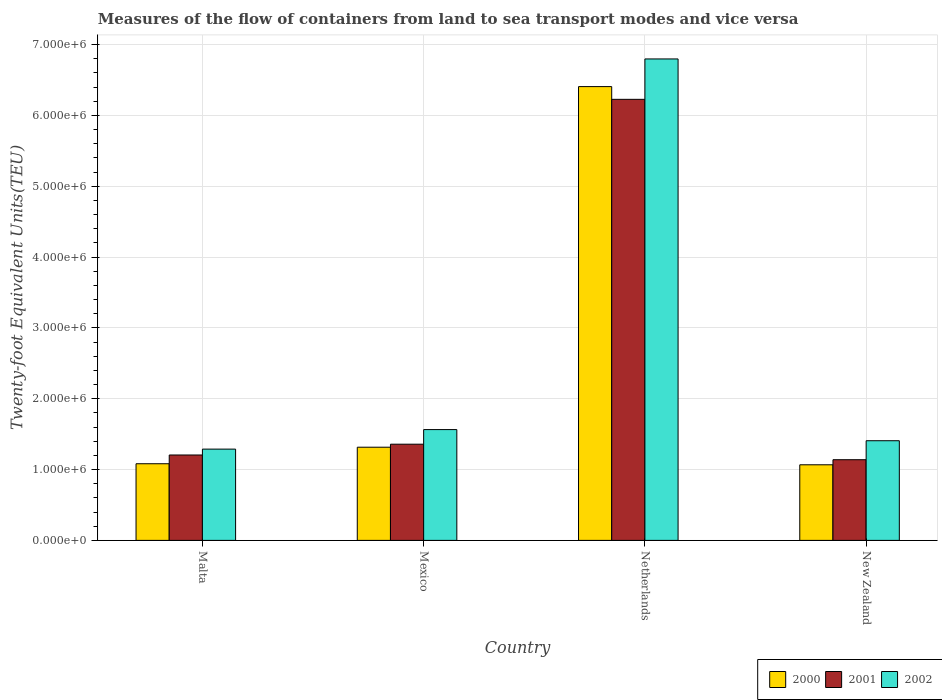How many different coloured bars are there?
Provide a succinct answer. 3. How many groups of bars are there?
Your answer should be very brief. 4. Are the number of bars on each tick of the X-axis equal?
Keep it short and to the point. Yes. How many bars are there on the 1st tick from the left?
Your answer should be very brief. 3. What is the label of the 3rd group of bars from the left?
Give a very brief answer. Netherlands. What is the container port traffic in 2001 in New Zealand?
Your response must be concise. 1.14e+06. Across all countries, what is the maximum container port traffic in 2001?
Your response must be concise. 6.23e+06. Across all countries, what is the minimum container port traffic in 2002?
Offer a very short reply. 1.29e+06. In which country was the container port traffic in 2000 maximum?
Provide a succinct answer. Netherlands. In which country was the container port traffic in 2000 minimum?
Offer a very short reply. New Zealand. What is the total container port traffic in 2000 in the graph?
Offer a terse response. 9.87e+06. What is the difference between the container port traffic in 2002 in Malta and that in Netherlands?
Ensure brevity in your answer.  -5.51e+06. What is the difference between the container port traffic in 2001 in New Zealand and the container port traffic in 2000 in Mexico?
Your answer should be very brief. -1.77e+05. What is the average container port traffic in 2002 per country?
Ensure brevity in your answer.  2.76e+06. What is the difference between the container port traffic of/in 2000 and container port traffic of/in 2001 in Mexico?
Offer a very short reply. -4.24e+04. What is the ratio of the container port traffic in 2001 in Malta to that in New Zealand?
Keep it short and to the point. 1.06. Is the container port traffic in 2000 in Malta less than that in Netherlands?
Provide a succinct answer. Yes. Is the difference between the container port traffic in 2000 in Malta and Mexico greater than the difference between the container port traffic in 2001 in Malta and Mexico?
Offer a terse response. No. What is the difference between the highest and the second highest container port traffic in 2002?
Your answer should be very brief. 5.23e+06. What is the difference between the highest and the lowest container port traffic in 2000?
Offer a terse response. 5.34e+06. In how many countries, is the container port traffic in 2002 greater than the average container port traffic in 2002 taken over all countries?
Your answer should be compact. 1. How many countries are there in the graph?
Offer a very short reply. 4. Does the graph contain any zero values?
Offer a very short reply. No. Where does the legend appear in the graph?
Offer a terse response. Bottom right. How many legend labels are there?
Provide a short and direct response. 3. What is the title of the graph?
Ensure brevity in your answer.  Measures of the flow of containers from land to sea transport modes and vice versa. What is the label or title of the Y-axis?
Offer a very short reply. Twenty-foot Equivalent Units(TEU). What is the Twenty-foot Equivalent Units(TEU) of 2000 in Malta?
Provide a short and direct response. 1.08e+06. What is the Twenty-foot Equivalent Units(TEU) in 2001 in Malta?
Offer a very short reply. 1.21e+06. What is the Twenty-foot Equivalent Units(TEU) in 2002 in Malta?
Make the answer very short. 1.29e+06. What is the Twenty-foot Equivalent Units(TEU) in 2000 in Mexico?
Keep it short and to the point. 1.32e+06. What is the Twenty-foot Equivalent Units(TEU) of 2001 in Mexico?
Your answer should be very brief. 1.36e+06. What is the Twenty-foot Equivalent Units(TEU) of 2002 in Mexico?
Offer a terse response. 1.56e+06. What is the Twenty-foot Equivalent Units(TEU) in 2000 in Netherlands?
Your answer should be very brief. 6.41e+06. What is the Twenty-foot Equivalent Units(TEU) of 2001 in Netherlands?
Your answer should be very brief. 6.23e+06. What is the Twenty-foot Equivalent Units(TEU) of 2002 in Netherlands?
Keep it short and to the point. 6.80e+06. What is the Twenty-foot Equivalent Units(TEU) of 2000 in New Zealand?
Provide a short and direct response. 1.07e+06. What is the Twenty-foot Equivalent Units(TEU) of 2001 in New Zealand?
Make the answer very short. 1.14e+06. What is the Twenty-foot Equivalent Units(TEU) in 2002 in New Zealand?
Make the answer very short. 1.41e+06. Across all countries, what is the maximum Twenty-foot Equivalent Units(TEU) in 2000?
Give a very brief answer. 6.41e+06. Across all countries, what is the maximum Twenty-foot Equivalent Units(TEU) in 2001?
Make the answer very short. 6.23e+06. Across all countries, what is the maximum Twenty-foot Equivalent Units(TEU) of 2002?
Your answer should be compact. 6.80e+06. Across all countries, what is the minimum Twenty-foot Equivalent Units(TEU) in 2000?
Your answer should be very brief. 1.07e+06. Across all countries, what is the minimum Twenty-foot Equivalent Units(TEU) of 2001?
Your response must be concise. 1.14e+06. Across all countries, what is the minimum Twenty-foot Equivalent Units(TEU) of 2002?
Provide a short and direct response. 1.29e+06. What is the total Twenty-foot Equivalent Units(TEU) of 2000 in the graph?
Offer a very short reply. 9.87e+06. What is the total Twenty-foot Equivalent Units(TEU) in 2001 in the graph?
Your answer should be compact. 9.93e+06. What is the total Twenty-foot Equivalent Units(TEU) in 2002 in the graph?
Provide a succinct answer. 1.11e+07. What is the difference between the Twenty-foot Equivalent Units(TEU) in 2000 in Malta and that in Mexico?
Your answer should be compact. -2.33e+05. What is the difference between the Twenty-foot Equivalent Units(TEU) of 2001 in Malta and that in Mexico?
Ensure brevity in your answer.  -1.52e+05. What is the difference between the Twenty-foot Equivalent Units(TEU) of 2002 in Malta and that in Mexico?
Provide a succinct answer. -2.76e+05. What is the difference between the Twenty-foot Equivalent Units(TEU) of 2000 in Malta and that in Netherlands?
Offer a terse response. -5.32e+06. What is the difference between the Twenty-foot Equivalent Units(TEU) of 2001 in Malta and that in Netherlands?
Your answer should be compact. -5.02e+06. What is the difference between the Twenty-foot Equivalent Units(TEU) of 2002 in Malta and that in Netherlands?
Offer a very short reply. -5.51e+06. What is the difference between the Twenty-foot Equivalent Units(TEU) of 2000 in Malta and that in New Zealand?
Give a very brief answer. 1.48e+04. What is the difference between the Twenty-foot Equivalent Units(TEU) in 2001 in Malta and that in New Zealand?
Ensure brevity in your answer.  6.66e+04. What is the difference between the Twenty-foot Equivalent Units(TEU) in 2002 in Malta and that in New Zealand?
Give a very brief answer. -1.18e+05. What is the difference between the Twenty-foot Equivalent Units(TEU) in 2000 in Mexico and that in Netherlands?
Offer a very short reply. -5.09e+06. What is the difference between the Twenty-foot Equivalent Units(TEU) of 2001 in Mexico and that in Netherlands?
Make the answer very short. -4.87e+06. What is the difference between the Twenty-foot Equivalent Units(TEU) of 2002 in Mexico and that in Netherlands?
Give a very brief answer. -5.23e+06. What is the difference between the Twenty-foot Equivalent Units(TEU) of 2000 in Mexico and that in New Zealand?
Your answer should be compact. 2.48e+05. What is the difference between the Twenty-foot Equivalent Units(TEU) of 2001 in Mexico and that in New Zealand?
Offer a terse response. 2.19e+05. What is the difference between the Twenty-foot Equivalent Units(TEU) of 2002 in Mexico and that in New Zealand?
Offer a terse response. 1.57e+05. What is the difference between the Twenty-foot Equivalent Units(TEU) in 2000 in Netherlands and that in New Zealand?
Offer a very short reply. 5.34e+06. What is the difference between the Twenty-foot Equivalent Units(TEU) of 2001 in Netherlands and that in New Zealand?
Keep it short and to the point. 5.09e+06. What is the difference between the Twenty-foot Equivalent Units(TEU) in 2002 in Netherlands and that in New Zealand?
Give a very brief answer. 5.39e+06. What is the difference between the Twenty-foot Equivalent Units(TEU) in 2000 in Malta and the Twenty-foot Equivalent Units(TEU) in 2001 in Mexico?
Give a very brief answer. -2.76e+05. What is the difference between the Twenty-foot Equivalent Units(TEU) of 2000 in Malta and the Twenty-foot Equivalent Units(TEU) of 2002 in Mexico?
Offer a terse response. -4.82e+05. What is the difference between the Twenty-foot Equivalent Units(TEU) in 2001 in Malta and the Twenty-foot Equivalent Units(TEU) in 2002 in Mexico?
Your answer should be compact. -3.59e+05. What is the difference between the Twenty-foot Equivalent Units(TEU) in 2000 in Malta and the Twenty-foot Equivalent Units(TEU) in 2001 in Netherlands?
Offer a very short reply. -5.15e+06. What is the difference between the Twenty-foot Equivalent Units(TEU) of 2000 in Malta and the Twenty-foot Equivalent Units(TEU) of 2002 in Netherlands?
Give a very brief answer. -5.72e+06. What is the difference between the Twenty-foot Equivalent Units(TEU) in 2001 in Malta and the Twenty-foot Equivalent Units(TEU) in 2002 in Netherlands?
Your answer should be compact. -5.59e+06. What is the difference between the Twenty-foot Equivalent Units(TEU) of 2000 in Malta and the Twenty-foot Equivalent Units(TEU) of 2001 in New Zealand?
Provide a short and direct response. -5.69e+04. What is the difference between the Twenty-foot Equivalent Units(TEU) in 2000 in Malta and the Twenty-foot Equivalent Units(TEU) in 2002 in New Zealand?
Make the answer very short. -3.25e+05. What is the difference between the Twenty-foot Equivalent Units(TEU) in 2001 in Malta and the Twenty-foot Equivalent Units(TEU) in 2002 in New Zealand?
Your response must be concise. -2.01e+05. What is the difference between the Twenty-foot Equivalent Units(TEU) of 2000 in Mexico and the Twenty-foot Equivalent Units(TEU) of 2001 in Netherlands?
Keep it short and to the point. -4.91e+06. What is the difference between the Twenty-foot Equivalent Units(TEU) of 2000 in Mexico and the Twenty-foot Equivalent Units(TEU) of 2002 in Netherlands?
Make the answer very short. -5.48e+06. What is the difference between the Twenty-foot Equivalent Units(TEU) of 2001 in Mexico and the Twenty-foot Equivalent Units(TEU) of 2002 in Netherlands?
Make the answer very short. -5.44e+06. What is the difference between the Twenty-foot Equivalent Units(TEU) in 2000 in Mexico and the Twenty-foot Equivalent Units(TEU) in 2001 in New Zealand?
Make the answer very short. 1.77e+05. What is the difference between the Twenty-foot Equivalent Units(TEU) in 2000 in Mexico and the Twenty-foot Equivalent Units(TEU) in 2002 in New Zealand?
Offer a very short reply. -9.14e+04. What is the difference between the Twenty-foot Equivalent Units(TEU) of 2001 in Mexico and the Twenty-foot Equivalent Units(TEU) of 2002 in New Zealand?
Provide a succinct answer. -4.90e+04. What is the difference between the Twenty-foot Equivalent Units(TEU) of 2000 in Netherlands and the Twenty-foot Equivalent Units(TEU) of 2001 in New Zealand?
Offer a very short reply. 5.27e+06. What is the difference between the Twenty-foot Equivalent Units(TEU) in 2000 in Netherlands and the Twenty-foot Equivalent Units(TEU) in 2002 in New Zealand?
Your response must be concise. 5.00e+06. What is the difference between the Twenty-foot Equivalent Units(TEU) in 2001 in Netherlands and the Twenty-foot Equivalent Units(TEU) in 2002 in New Zealand?
Provide a short and direct response. 4.82e+06. What is the average Twenty-foot Equivalent Units(TEU) of 2000 per country?
Make the answer very short. 2.47e+06. What is the average Twenty-foot Equivalent Units(TEU) of 2001 per country?
Provide a succinct answer. 2.48e+06. What is the average Twenty-foot Equivalent Units(TEU) in 2002 per country?
Provide a succinct answer. 2.76e+06. What is the difference between the Twenty-foot Equivalent Units(TEU) of 2000 and Twenty-foot Equivalent Units(TEU) of 2001 in Malta?
Your answer should be compact. -1.24e+05. What is the difference between the Twenty-foot Equivalent Units(TEU) of 2000 and Twenty-foot Equivalent Units(TEU) of 2002 in Malta?
Give a very brief answer. -2.07e+05. What is the difference between the Twenty-foot Equivalent Units(TEU) of 2001 and Twenty-foot Equivalent Units(TEU) of 2002 in Malta?
Your answer should be very brief. -8.30e+04. What is the difference between the Twenty-foot Equivalent Units(TEU) of 2000 and Twenty-foot Equivalent Units(TEU) of 2001 in Mexico?
Offer a very short reply. -4.24e+04. What is the difference between the Twenty-foot Equivalent Units(TEU) in 2000 and Twenty-foot Equivalent Units(TEU) in 2002 in Mexico?
Your answer should be compact. -2.49e+05. What is the difference between the Twenty-foot Equivalent Units(TEU) in 2001 and Twenty-foot Equivalent Units(TEU) in 2002 in Mexico?
Offer a terse response. -2.06e+05. What is the difference between the Twenty-foot Equivalent Units(TEU) of 2000 and Twenty-foot Equivalent Units(TEU) of 2001 in Netherlands?
Offer a terse response. 1.80e+05. What is the difference between the Twenty-foot Equivalent Units(TEU) in 2000 and Twenty-foot Equivalent Units(TEU) in 2002 in Netherlands?
Provide a short and direct response. -3.90e+05. What is the difference between the Twenty-foot Equivalent Units(TEU) in 2001 and Twenty-foot Equivalent Units(TEU) in 2002 in Netherlands?
Give a very brief answer. -5.70e+05. What is the difference between the Twenty-foot Equivalent Units(TEU) in 2000 and Twenty-foot Equivalent Units(TEU) in 2001 in New Zealand?
Ensure brevity in your answer.  -7.17e+04. What is the difference between the Twenty-foot Equivalent Units(TEU) in 2000 and Twenty-foot Equivalent Units(TEU) in 2002 in New Zealand?
Keep it short and to the point. -3.40e+05. What is the difference between the Twenty-foot Equivalent Units(TEU) in 2001 and Twenty-foot Equivalent Units(TEU) in 2002 in New Zealand?
Your answer should be very brief. -2.68e+05. What is the ratio of the Twenty-foot Equivalent Units(TEU) of 2000 in Malta to that in Mexico?
Make the answer very short. 0.82. What is the ratio of the Twenty-foot Equivalent Units(TEU) in 2001 in Malta to that in Mexico?
Provide a succinct answer. 0.89. What is the ratio of the Twenty-foot Equivalent Units(TEU) in 2002 in Malta to that in Mexico?
Offer a terse response. 0.82. What is the ratio of the Twenty-foot Equivalent Units(TEU) of 2000 in Malta to that in Netherlands?
Provide a succinct answer. 0.17. What is the ratio of the Twenty-foot Equivalent Units(TEU) in 2001 in Malta to that in Netherlands?
Offer a terse response. 0.19. What is the ratio of the Twenty-foot Equivalent Units(TEU) in 2002 in Malta to that in Netherlands?
Make the answer very short. 0.19. What is the ratio of the Twenty-foot Equivalent Units(TEU) in 2000 in Malta to that in New Zealand?
Offer a terse response. 1.01. What is the ratio of the Twenty-foot Equivalent Units(TEU) of 2001 in Malta to that in New Zealand?
Provide a short and direct response. 1.06. What is the ratio of the Twenty-foot Equivalent Units(TEU) of 2002 in Malta to that in New Zealand?
Give a very brief answer. 0.92. What is the ratio of the Twenty-foot Equivalent Units(TEU) of 2000 in Mexico to that in Netherlands?
Make the answer very short. 0.21. What is the ratio of the Twenty-foot Equivalent Units(TEU) of 2001 in Mexico to that in Netherlands?
Ensure brevity in your answer.  0.22. What is the ratio of the Twenty-foot Equivalent Units(TEU) of 2002 in Mexico to that in Netherlands?
Ensure brevity in your answer.  0.23. What is the ratio of the Twenty-foot Equivalent Units(TEU) in 2000 in Mexico to that in New Zealand?
Keep it short and to the point. 1.23. What is the ratio of the Twenty-foot Equivalent Units(TEU) of 2001 in Mexico to that in New Zealand?
Make the answer very short. 1.19. What is the ratio of the Twenty-foot Equivalent Units(TEU) in 2002 in Mexico to that in New Zealand?
Offer a very short reply. 1.11. What is the ratio of the Twenty-foot Equivalent Units(TEU) in 2000 in Netherlands to that in New Zealand?
Offer a very short reply. 6. What is the ratio of the Twenty-foot Equivalent Units(TEU) of 2001 in Netherlands to that in New Zealand?
Keep it short and to the point. 5.47. What is the ratio of the Twenty-foot Equivalent Units(TEU) in 2002 in Netherlands to that in New Zealand?
Keep it short and to the point. 4.83. What is the difference between the highest and the second highest Twenty-foot Equivalent Units(TEU) of 2000?
Ensure brevity in your answer.  5.09e+06. What is the difference between the highest and the second highest Twenty-foot Equivalent Units(TEU) of 2001?
Offer a terse response. 4.87e+06. What is the difference between the highest and the second highest Twenty-foot Equivalent Units(TEU) in 2002?
Provide a succinct answer. 5.23e+06. What is the difference between the highest and the lowest Twenty-foot Equivalent Units(TEU) of 2000?
Your answer should be compact. 5.34e+06. What is the difference between the highest and the lowest Twenty-foot Equivalent Units(TEU) in 2001?
Make the answer very short. 5.09e+06. What is the difference between the highest and the lowest Twenty-foot Equivalent Units(TEU) of 2002?
Ensure brevity in your answer.  5.51e+06. 